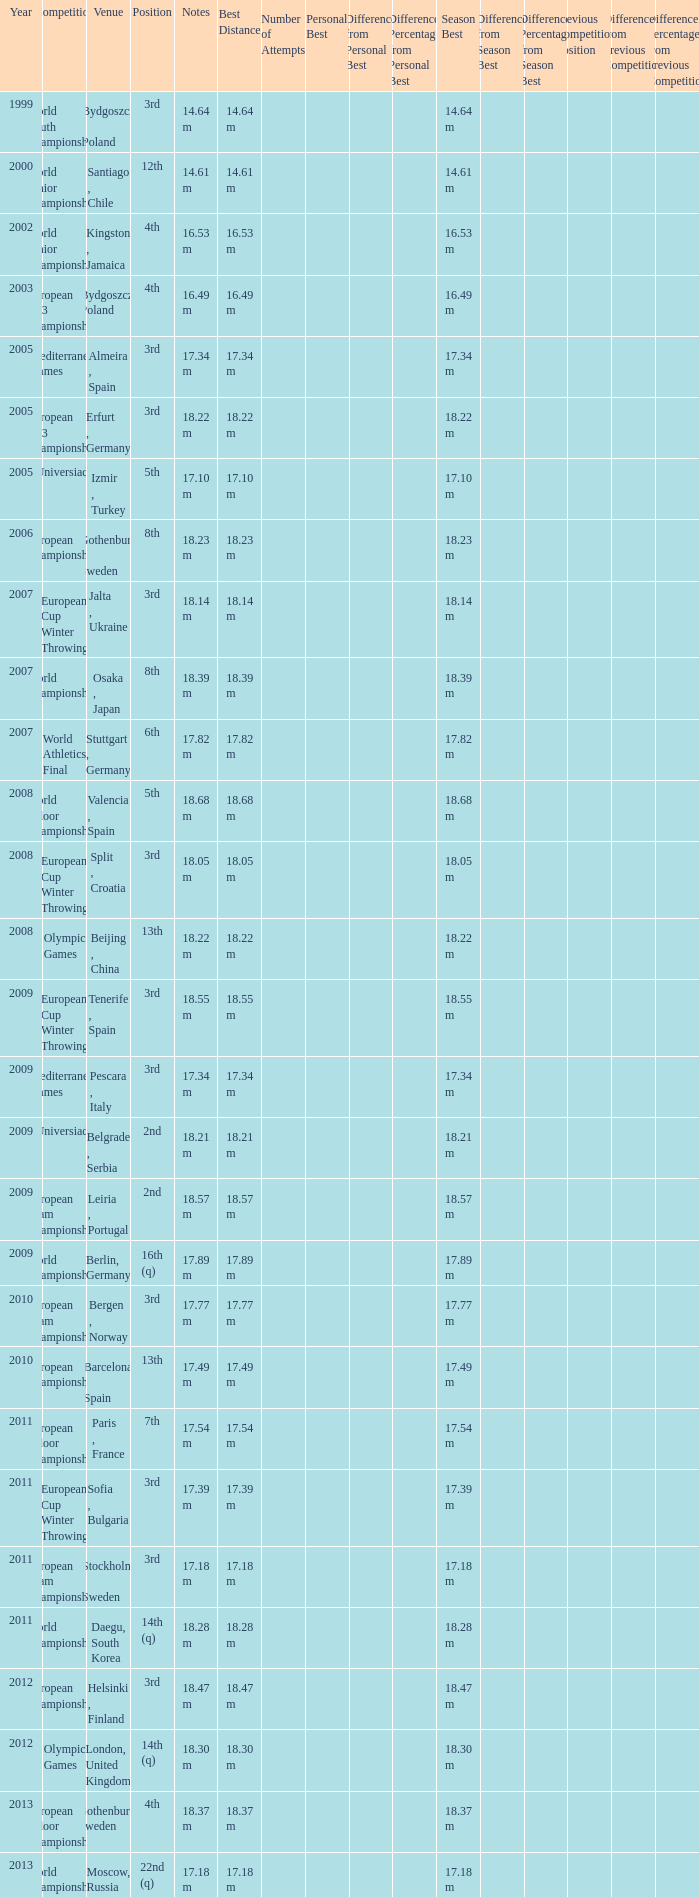What are the notes for bydgoszcz, Poland? 14.64 m, 16.49 m. 